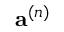<formula> <loc_0><loc_0><loc_500><loc_500>a ^ { ( n ) }</formula> 